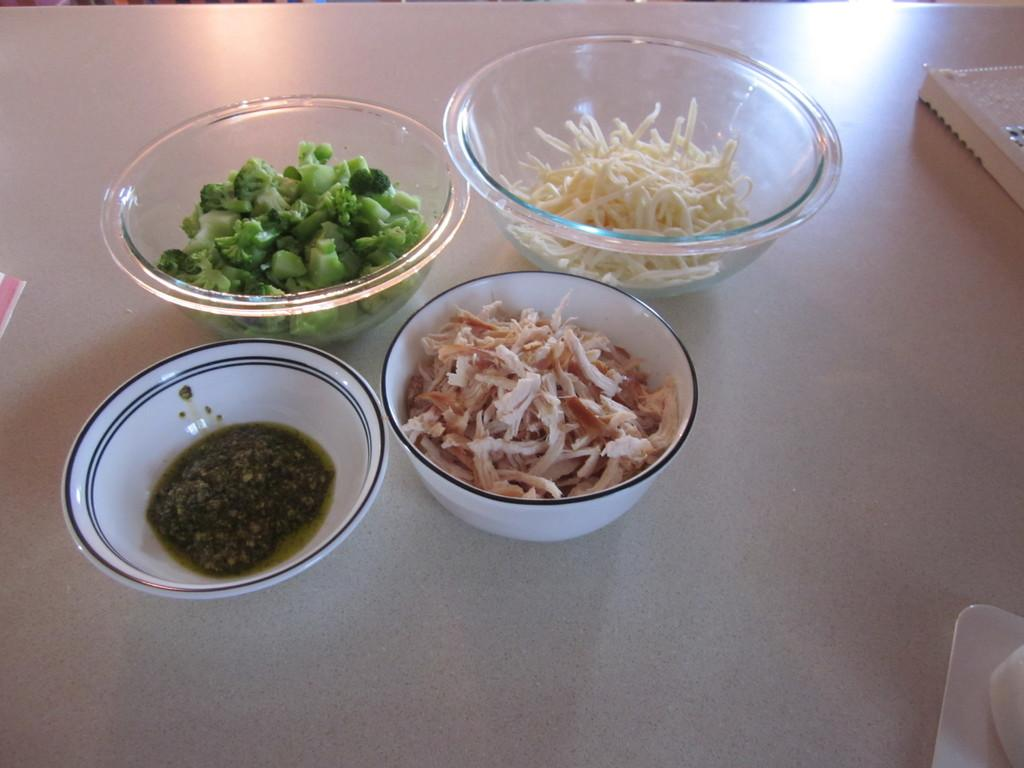How many bowls are visible in the image? There are four bowls in the image. What is in each of the bowls? Each bowl contains food items. Where are the bowls located in the image? The bowls are on a table at the bottom of the image. What type of icicle can be seen hanging from the table in the image? There is no icicle present in the image; it is indoors and not cold enough for icicles to form. 